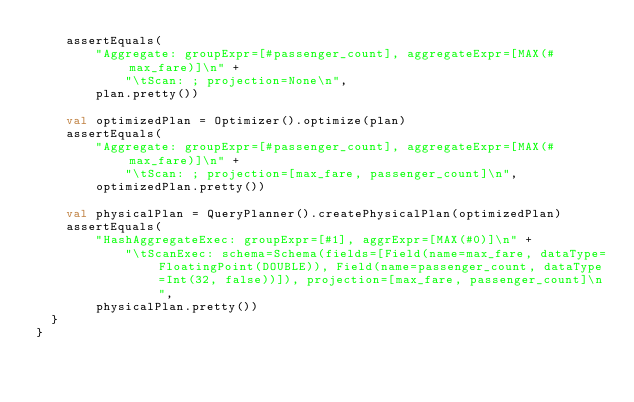<code> <loc_0><loc_0><loc_500><loc_500><_Kotlin_>    assertEquals(
        "Aggregate: groupExpr=[#passenger_count], aggregateExpr=[MAX(#max_fare)]\n" +
            "\tScan: ; projection=None\n",
        plan.pretty())

    val optimizedPlan = Optimizer().optimize(plan)
    assertEquals(
        "Aggregate: groupExpr=[#passenger_count], aggregateExpr=[MAX(#max_fare)]\n" +
            "\tScan: ; projection=[max_fare, passenger_count]\n",
        optimizedPlan.pretty())

    val physicalPlan = QueryPlanner().createPhysicalPlan(optimizedPlan)
    assertEquals(
        "HashAggregateExec: groupExpr=[#1], aggrExpr=[MAX(#0)]\n" +
            "\tScanExec: schema=Schema(fields=[Field(name=max_fare, dataType=FloatingPoint(DOUBLE)), Field(name=passenger_count, dataType=Int(32, false))]), projection=[max_fare, passenger_count]\n",
        physicalPlan.pretty())
  }
}
</code> 